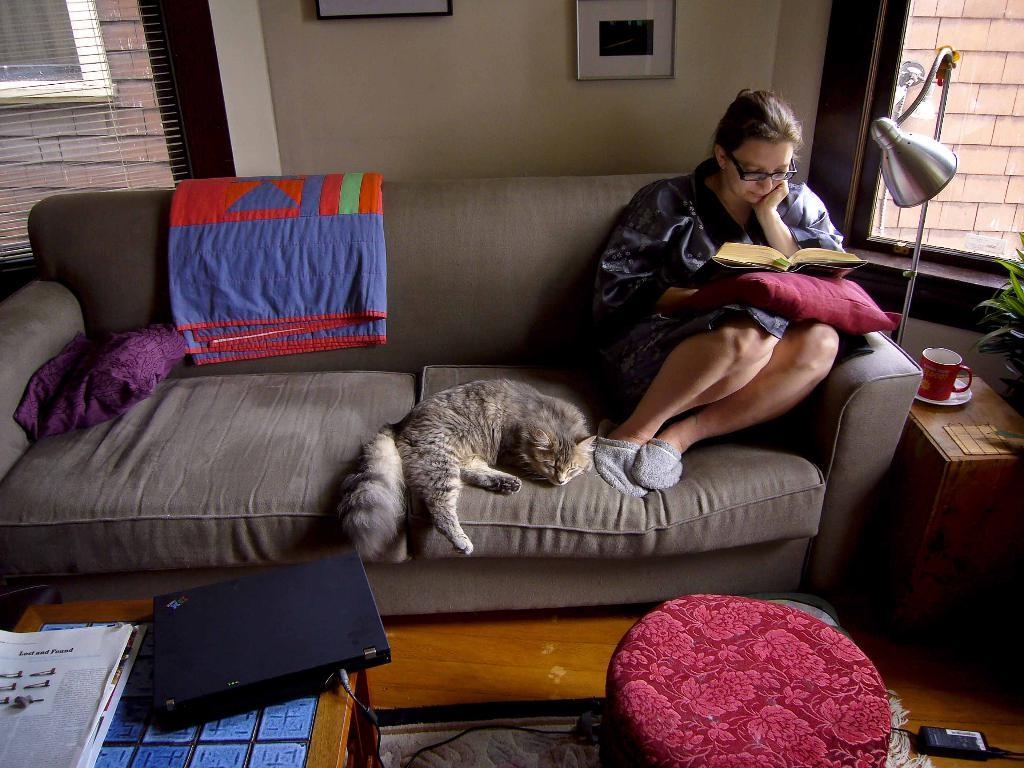Who is present in the image? There is a woman in the image. What is the woman doing in the image? The woman is sitting on a sofa. Is there any other living creature with the woman? Yes, there is a cat with the woman. What object can be seen on a table in the image? There is a laptop on a table in the image. What type of leaf is being used as a bookmark in the image? There is no leaf present in the image, nor is there any indication of a book or a bookmark. 